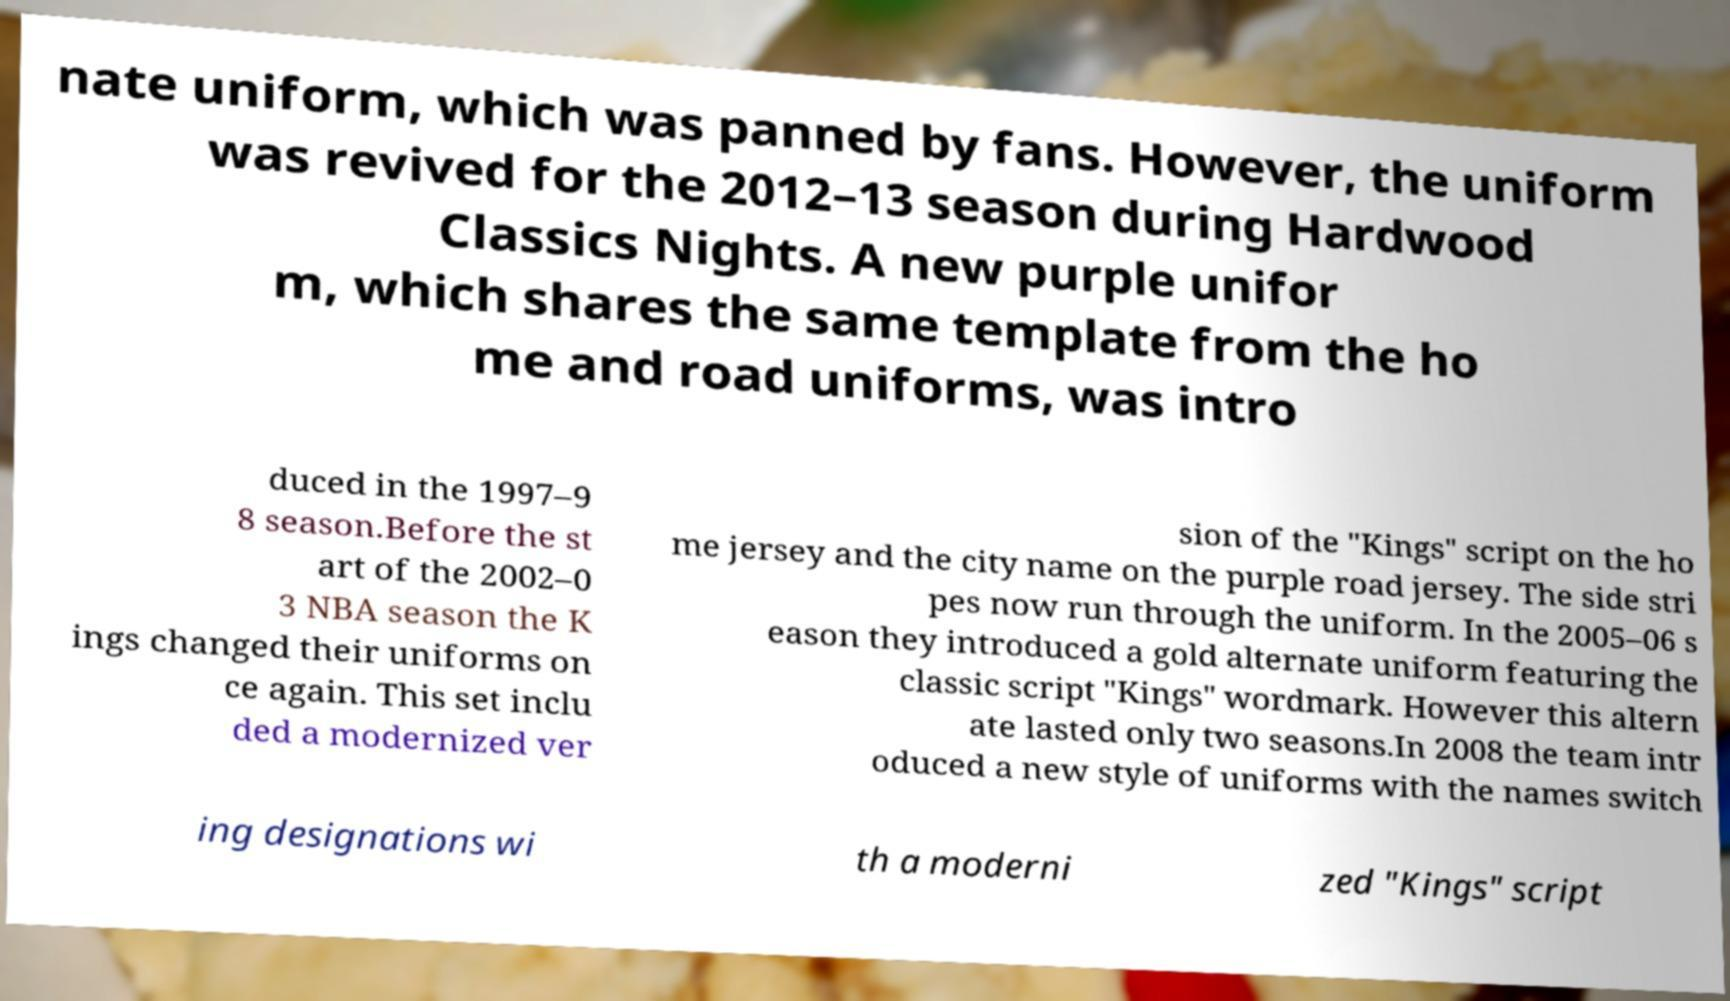Could you extract and type out the text from this image? nate uniform, which was panned by fans. However, the uniform was revived for the 2012–13 season during Hardwood Classics Nights. A new purple unifor m, which shares the same template from the ho me and road uniforms, was intro duced in the 1997–9 8 season.Before the st art of the 2002–0 3 NBA season the K ings changed their uniforms on ce again. This set inclu ded a modernized ver sion of the "Kings" script on the ho me jersey and the city name on the purple road jersey. The side stri pes now run through the uniform. In the 2005–06 s eason they introduced a gold alternate uniform featuring the classic script "Kings" wordmark. However this altern ate lasted only two seasons.In 2008 the team intr oduced a new style of uniforms with the names switch ing designations wi th a moderni zed "Kings" script 